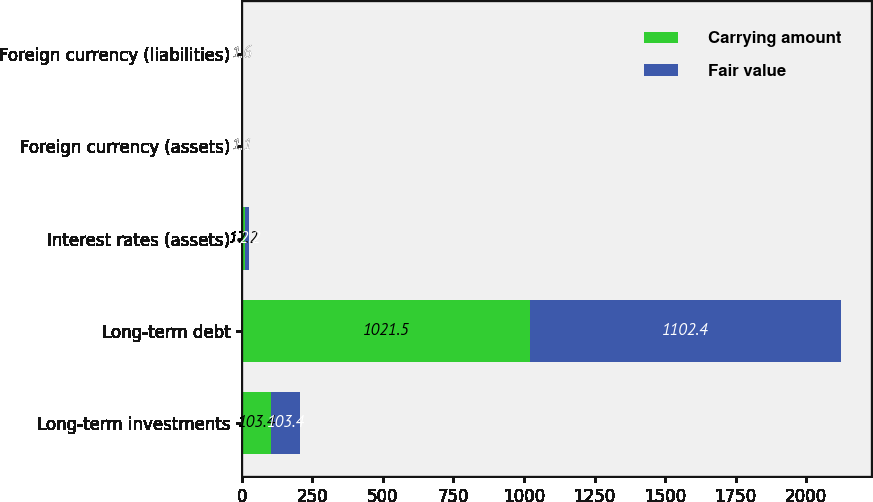Convert chart to OTSL. <chart><loc_0><loc_0><loc_500><loc_500><stacked_bar_chart><ecel><fcel>Long-term investments<fcel>Long-term debt<fcel>Interest rates (assets)<fcel>Foreign currency (assets)<fcel>Foreign currency (liabilities)<nl><fcel>Carrying amount<fcel>103.4<fcel>1021.5<fcel>12.2<fcel>1.1<fcel>1.6<nl><fcel>Fair value<fcel>103.4<fcel>1102.4<fcel>12.2<fcel>1.1<fcel>1.6<nl></chart> 